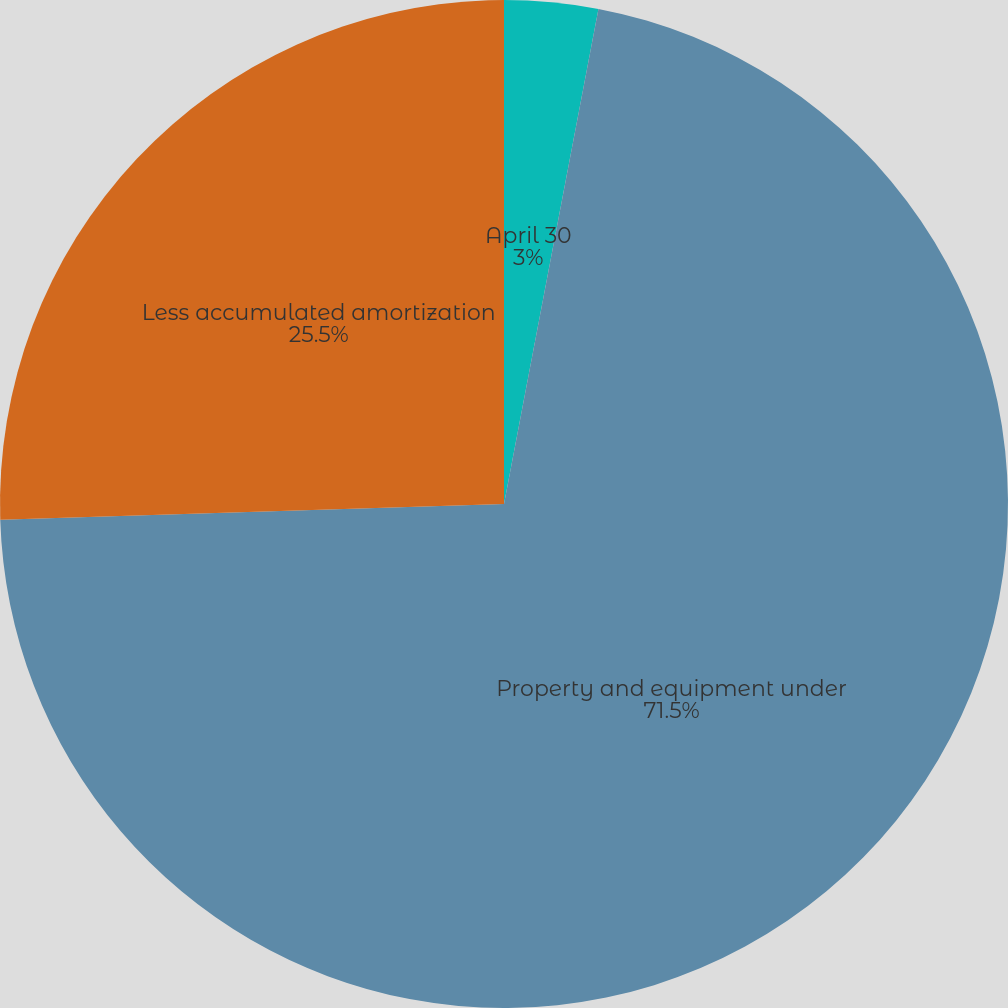Convert chart to OTSL. <chart><loc_0><loc_0><loc_500><loc_500><pie_chart><fcel>April 30<fcel>Property and equipment under<fcel>Less accumulated amortization<nl><fcel>3.0%<fcel>71.5%<fcel>25.5%<nl></chart> 